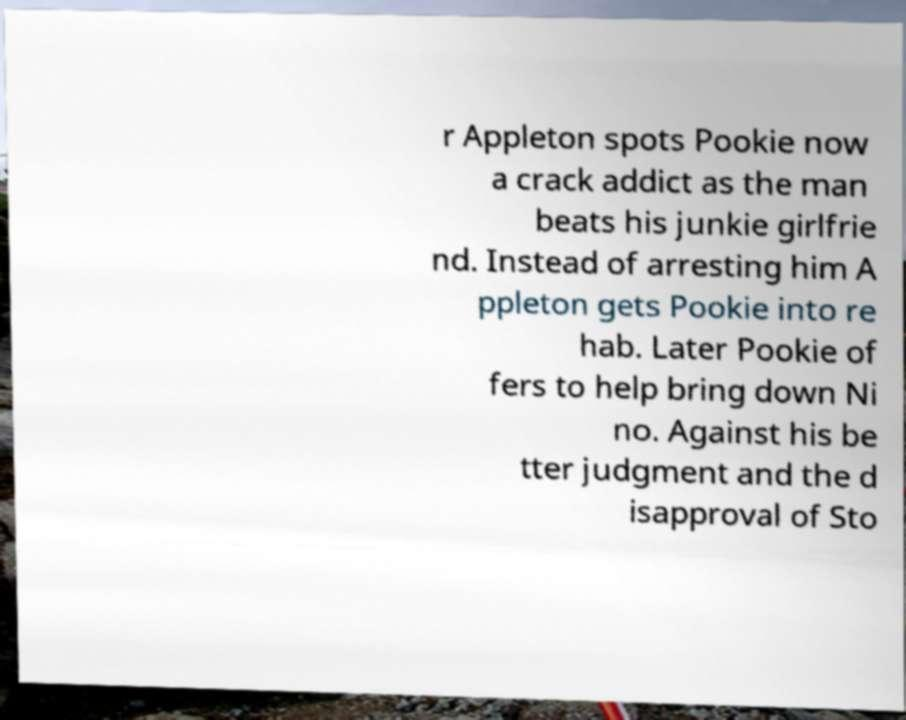I need the written content from this picture converted into text. Can you do that? r Appleton spots Pookie now a crack addict as the man beats his junkie girlfrie nd. Instead of arresting him A ppleton gets Pookie into re hab. Later Pookie of fers to help bring down Ni no. Against his be tter judgment and the d isapproval of Sto 